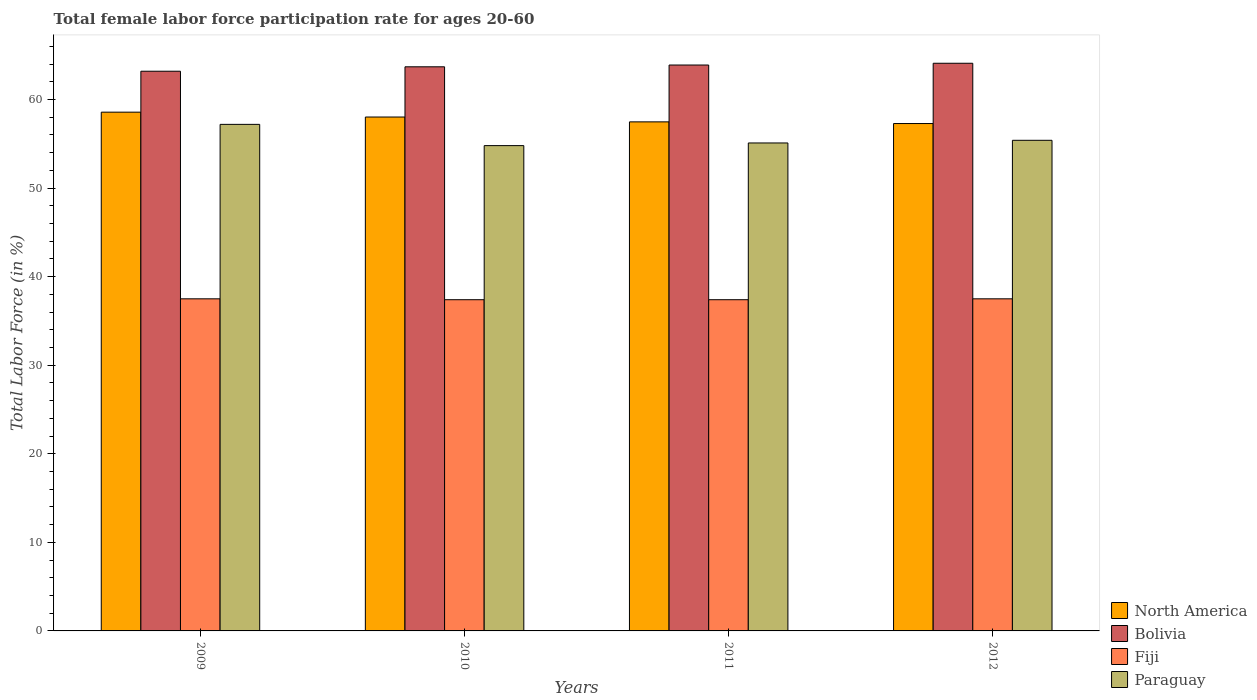How many different coloured bars are there?
Offer a terse response. 4. Are the number of bars per tick equal to the number of legend labels?
Ensure brevity in your answer.  Yes. How many bars are there on the 4th tick from the left?
Your answer should be compact. 4. What is the female labor force participation rate in Paraguay in 2011?
Offer a terse response. 55.1. Across all years, what is the maximum female labor force participation rate in North America?
Offer a very short reply. 58.58. Across all years, what is the minimum female labor force participation rate in Bolivia?
Provide a short and direct response. 63.2. What is the total female labor force participation rate in Fiji in the graph?
Your response must be concise. 149.8. What is the difference between the female labor force participation rate in North America in 2009 and that in 2010?
Keep it short and to the point. 0.55. What is the difference between the female labor force participation rate in Paraguay in 2009 and the female labor force participation rate in Fiji in 2012?
Provide a succinct answer. 19.7. What is the average female labor force participation rate in North America per year?
Offer a terse response. 57.85. In the year 2009, what is the difference between the female labor force participation rate in Fiji and female labor force participation rate in North America?
Provide a succinct answer. -21.08. In how many years, is the female labor force participation rate in North America greater than 4 %?
Your answer should be compact. 4. What is the ratio of the female labor force participation rate in Paraguay in 2009 to that in 2011?
Provide a succinct answer. 1.04. What is the difference between the highest and the second highest female labor force participation rate in Paraguay?
Give a very brief answer. 1.8. What is the difference between the highest and the lowest female labor force participation rate in North America?
Your response must be concise. 1.28. Is the sum of the female labor force participation rate in North America in 2011 and 2012 greater than the maximum female labor force participation rate in Bolivia across all years?
Provide a succinct answer. Yes. What does the 4th bar from the left in 2009 represents?
Offer a terse response. Paraguay. Is it the case that in every year, the sum of the female labor force participation rate in North America and female labor force participation rate in Paraguay is greater than the female labor force participation rate in Fiji?
Give a very brief answer. Yes. How many bars are there?
Your answer should be very brief. 16. How many years are there in the graph?
Provide a succinct answer. 4. What is the difference between two consecutive major ticks on the Y-axis?
Ensure brevity in your answer.  10. Does the graph contain grids?
Offer a very short reply. No. Where does the legend appear in the graph?
Your answer should be very brief. Bottom right. How are the legend labels stacked?
Give a very brief answer. Vertical. What is the title of the graph?
Your response must be concise. Total female labor force participation rate for ages 20-60. Does "Timor-Leste" appear as one of the legend labels in the graph?
Ensure brevity in your answer.  No. What is the Total Labor Force (in %) of North America in 2009?
Offer a terse response. 58.58. What is the Total Labor Force (in %) of Bolivia in 2009?
Your answer should be very brief. 63.2. What is the Total Labor Force (in %) in Fiji in 2009?
Your response must be concise. 37.5. What is the Total Labor Force (in %) in Paraguay in 2009?
Your answer should be compact. 57.2. What is the Total Labor Force (in %) in North America in 2010?
Offer a very short reply. 58.03. What is the Total Labor Force (in %) of Bolivia in 2010?
Keep it short and to the point. 63.7. What is the Total Labor Force (in %) in Fiji in 2010?
Your answer should be very brief. 37.4. What is the Total Labor Force (in %) of Paraguay in 2010?
Make the answer very short. 54.8. What is the Total Labor Force (in %) in North America in 2011?
Make the answer very short. 57.48. What is the Total Labor Force (in %) in Bolivia in 2011?
Offer a very short reply. 63.9. What is the Total Labor Force (in %) of Fiji in 2011?
Provide a short and direct response. 37.4. What is the Total Labor Force (in %) of Paraguay in 2011?
Provide a short and direct response. 55.1. What is the Total Labor Force (in %) of North America in 2012?
Offer a terse response. 57.29. What is the Total Labor Force (in %) in Bolivia in 2012?
Provide a succinct answer. 64.1. What is the Total Labor Force (in %) of Fiji in 2012?
Your answer should be compact. 37.5. What is the Total Labor Force (in %) of Paraguay in 2012?
Ensure brevity in your answer.  55.4. Across all years, what is the maximum Total Labor Force (in %) of North America?
Offer a very short reply. 58.58. Across all years, what is the maximum Total Labor Force (in %) of Bolivia?
Give a very brief answer. 64.1. Across all years, what is the maximum Total Labor Force (in %) in Fiji?
Make the answer very short. 37.5. Across all years, what is the maximum Total Labor Force (in %) in Paraguay?
Your answer should be compact. 57.2. Across all years, what is the minimum Total Labor Force (in %) of North America?
Offer a very short reply. 57.29. Across all years, what is the minimum Total Labor Force (in %) of Bolivia?
Keep it short and to the point. 63.2. Across all years, what is the minimum Total Labor Force (in %) in Fiji?
Offer a terse response. 37.4. Across all years, what is the minimum Total Labor Force (in %) of Paraguay?
Provide a succinct answer. 54.8. What is the total Total Labor Force (in %) in North America in the graph?
Give a very brief answer. 231.38. What is the total Total Labor Force (in %) in Bolivia in the graph?
Your answer should be very brief. 254.9. What is the total Total Labor Force (in %) of Fiji in the graph?
Your response must be concise. 149.8. What is the total Total Labor Force (in %) in Paraguay in the graph?
Provide a short and direct response. 222.5. What is the difference between the Total Labor Force (in %) in North America in 2009 and that in 2010?
Give a very brief answer. 0.55. What is the difference between the Total Labor Force (in %) in Bolivia in 2009 and that in 2010?
Your response must be concise. -0.5. What is the difference between the Total Labor Force (in %) in Fiji in 2009 and that in 2010?
Make the answer very short. 0.1. What is the difference between the Total Labor Force (in %) in North America in 2009 and that in 2011?
Offer a terse response. 1.1. What is the difference between the Total Labor Force (in %) in North America in 2009 and that in 2012?
Provide a short and direct response. 1.28. What is the difference between the Total Labor Force (in %) in Fiji in 2009 and that in 2012?
Your answer should be compact. 0. What is the difference between the Total Labor Force (in %) in North America in 2010 and that in 2011?
Provide a short and direct response. 0.55. What is the difference between the Total Labor Force (in %) of Bolivia in 2010 and that in 2011?
Provide a short and direct response. -0.2. What is the difference between the Total Labor Force (in %) of Paraguay in 2010 and that in 2011?
Your response must be concise. -0.3. What is the difference between the Total Labor Force (in %) in North America in 2010 and that in 2012?
Provide a short and direct response. 0.74. What is the difference between the Total Labor Force (in %) in Paraguay in 2010 and that in 2012?
Make the answer very short. -0.6. What is the difference between the Total Labor Force (in %) in North America in 2011 and that in 2012?
Ensure brevity in your answer.  0.19. What is the difference between the Total Labor Force (in %) of Paraguay in 2011 and that in 2012?
Give a very brief answer. -0.3. What is the difference between the Total Labor Force (in %) in North America in 2009 and the Total Labor Force (in %) in Bolivia in 2010?
Your answer should be very brief. -5.12. What is the difference between the Total Labor Force (in %) in North America in 2009 and the Total Labor Force (in %) in Fiji in 2010?
Offer a terse response. 21.18. What is the difference between the Total Labor Force (in %) in North America in 2009 and the Total Labor Force (in %) in Paraguay in 2010?
Provide a succinct answer. 3.78. What is the difference between the Total Labor Force (in %) in Bolivia in 2009 and the Total Labor Force (in %) in Fiji in 2010?
Your answer should be very brief. 25.8. What is the difference between the Total Labor Force (in %) in Bolivia in 2009 and the Total Labor Force (in %) in Paraguay in 2010?
Ensure brevity in your answer.  8.4. What is the difference between the Total Labor Force (in %) in Fiji in 2009 and the Total Labor Force (in %) in Paraguay in 2010?
Offer a very short reply. -17.3. What is the difference between the Total Labor Force (in %) in North America in 2009 and the Total Labor Force (in %) in Bolivia in 2011?
Make the answer very short. -5.32. What is the difference between the Total Labor Force (in %) in North America in 2009 and the Total Labor Force (in %) in Fiji in 2011?
Give a very brief answer. 21.18. What is the difference between the Total Labor Force (in %) in North America in 2009 and the Total Labor Force (in %) in Paraguay in 2011?
Keep it short and to the point. 3.48. What is the difference between the Total Labor Force (in %) of Bolivia in 2009 and the Total Labor Force (in %) of Fiji in 2011?
Your answer should be compact. 25.8. What is the difference between the Total Labor Force (in %) of Bolivia in 2009 and the Total Labor Force (in %) of Paraguay in 2011?
Ensure brevity in your answer.  8.1. What is the difference between the Total Labor Force (in %) of Fiji in 2009 and the Total Labor Force (in %) of Paraguay in 2011?
Your answer should be very brief. -17.6. What is the difference between the Total Labor Force (in %) of North America in 2009 and the Total Labor Force (in %) of Bolivia in 2012?
Give a very brief answer. -5.52. What is the difference between the Total Labor Force (in %) in North America in 2009 and the Total Labor Force (in %) in Fiji in 2012?
Your answer should be very brief. 21.08. What is the difference between the Total Labor Force (in %) in North America in 2009 and the Total Labor Force (in %) in Paraguay in 2012?
Keep it short and to the point. 3.18. What is the difference between the Total Labor Force (in %) of Bolivia in 2009 and the Total Labor Force (in %) of Fiji in 2012?
Ensure brevity in your answer.  25.7. What is the difference between the Total Labor Force (in %) in Bolivia in 2009 and the Total Labor Force (in %) in Paraguay in 2012?
Give a very brief answer. 7.8. What is the difference between the Total Labor Force (in %) in Fiji in 2009 and the Total Labor Force (in %) in Paraguay in 2012?
Keep it short and to the point. -17.9. What is the difference between the Total Labor Force (in %) in North America in 2010 and the Total Labor Force (in %) in Bolivia in 2011?
Ensure brevity in your answer.  -5.87. What is the difference between the Total Labor Force (in %) in North America in 2010 and the Total Labor Force (in %) in Fiji in 2011?
Provide a succinct answer. 20.63. What is the difference between the Total Labor Force (in %) in North America in 2010 and the Total Labor Force (in %) in Paraguay in 2011?
Ensure brevity in your answer.  2.93. What is the difference between the Total Labor Force (in %) in Bolivia in 2010 and the Total Labor Force (in %) in Fiji in 2011?
Ensure brevity in your answer.  26.3. What is the difference between the Total Labor Force (in %) of Bolivia in 2010 and the Total Labor Force (in %) of Paraguay in 2011?
Provide a short and direct response. 8.6. What is the difference between the Total Labor Force (in %) of Fiji in 2010 and the Total Labor Force (in %) of Paraguay in 2011?
Your answer should be very brief. -17.7. What is the difference between the Total Labor Force (in %) in North America in 2010 and the Total Labor Force (in %) in Bolivia in 2012?
Make the answer very short. -6.07. What is the difference between the Total Labor Force (in %) in North America in 2010 and the Total Labor Force (in %) in Fiji in 2012?
Provide a short and direct response. 20.53. What is the difference between the Total Labor Force (in %) in North America in 2010 and the Total Labor Force (in %) in Paraguay in 2012?
Your response must be concise. 2.63. What is the difference between the Total Labor Force (in %) of Bolivia in 2010 and the Total Labor Force (in %) of Fiji in 2012?
Offer a very short reply. 26.2. What is the difference between the Total Labor Force (in %) of Bolivia in 2010 and the Total Labor Force (in %) of Paraguay in 2012?
Your answer should be compact. 8.3. What is the difference between the Total Labor Force (in %) of Fiji in 2010 and the Total Labor Force (in %) of Paraguay in 2012?
Give a very brief answer. -18. What is the difference between the Total Labor Force (in %) of North America in 2011 and the Total Labor Force (in %) of Bolivia in 2012?
Offer a very short reply. -6.62. What is the difference between the Total Labor Force (in %) in North America in 2011 and the Total Labor Force (in %) in Fiji in 2012?
Provide a short and direct response. 19.98. What is the difference between the Total Labor Force (in %) in North America in 2011 and the Total Labor Force (in %) in Paraguay in 2012?
Your answer should be very brief. 2.08. What is the difference between the Total Labor Force (in %) in Bolivia in 2011 and the Total Labor Force (in %) in Fiji in 2012?
Your answer should be very brief. 26.4. What is the difference between the Total Labor Force (in %) of Bolivia in 2011 and the Total Labor Force (in %) of Paraguay in 2012?
Make the answer very short. 8.5. What is the average Total Labor Force (in %) in North America per year?
Your answer should be compact. 57.85. What is the average Total Labor Force (in %) of Bolivia per year?
Give a very brief answer. 63.73. What is the average Total Labor Force (in %) of Fiji per year?
Give a very brief answer. 37.45. What is the average Total Labor Force (in %) in Paraguay per year?
Ensure brevity in your answer.  55.62. In the year 2009, what is the difference between the Total Labor Force (in %) in North America and Total Labor Force (in %) in Bolivia?
Keep it short and to the point. -4.62. In the year 2009, what is the difference between the Total Labor Force (in %) in North America and Total Labor Force (in %) in Fiji?
Give a very brief answer. 21.08. In the year 2009, what is the difference between the Total Labor Force (in %) of North America and Total Labor Force (in %) of Paraguay?
Make the answer very short. 1.38. In the year 2009, what is the difference between the Total Labor Force (in %) of Bolivia and Total Labor Force (in %) of Fiji?
Offer a very short reply. 25.7. In the year 2009, what is the difference between the Total Labor Force (in %) of Bolivia and Total Labor Force (in %) of Paraguay?
Provide a short and direct response. 6. In the year 2009, what is the difference between the Total Labor Force (in %) in Fiji and Total Labor Force (in %) in Paraguay?
Give a very brief answer. -19.7. In the year 2010, what is the difference between the Total Labor Force (in %) of North America and Total Labor Force (in %) of Bolivia?
Make the answer very short. -5.67. In the year 2010, what is the difference between the Total Labor Force (in %) of North America and Total Labor Force (in %) of Fiji?
Your answer should be very brief. 20.63. In the year 2010, what is the difference between the Total Labor Force (in %) in North America and Total Labor Force (in %) in Paraguay?
Make the answer very short. 3.23. In the year 2010, what is the difference between the Total Labor Force (in %) of Bolivia and Total Labor Force (in %) of Fiji?
Provide a succinct answer. 26.3. In the year 2010, what is the difference between the Total Labor Force (in %) in Fiji and Total Labor Force (in %) in Paraguay?
Give a very brief answer. -17.4. In the year 2011, what is the difference between the Total Labor Force (in %) of North America and Total Labor Force (in %) of Bolivia?
Ensure brevity in your answer.  -6.42. In the year 2011, what is the difference between the Total Labor Force (in %) in North America and Total Labor Force (in %) in Fiji?
Make the answer very short. 20.08. In the year 2011, what is the difference between the Total Labor Force (in %) of North America and Total Labor Force (in %) of Paraguay?
Provide a short and direct response. 2.38. In the year 2011, what is the difference between the Total Labor Force (in %) of Bolivia and Total Labor Force (in %) of Paraguay?
Ensure brevity in your answer.  8.8. In the year 2011, what is the difference between the Total Labor Force (in %) of Fiji and Total Labor Force (in %) of Paraguay?
Make the answer very short. -17.7. In the year 2012, what is the difference between the Total Labor Force (in %) in North America and Total Labor Force (in %) in Bolivia?
Your answer should be very brief. -6.81. In the year 2012, what is the difference between the Total Labor Force (in %) of North America and Total Labor Force (in %) of Fiji?
Offer a terse response. 19.79. In the year 2012, what is the difference between the Total Labor Force (in %) of North America and Total Labor Force (in %) of Paraguay?
Your answer should be very brief. 1.89. In the year 2012, what is the difference between the Total Labor Force (in %) of Bolivia and Total Labor Force (in %) of Fiji?
Your answer should be very brief. 26.6. In the year 2012, what is the difference between the Total Labor Force (in %) in Bolivia and Total Labor Force (in %) in Paraguay?
Your response must be concise. 8.7. In the year 2012, what is the difference between the Total Labor Force (in %) in Fiji and Total Labor Force (in %) in Paraguay?
Keep it short and to the point. -17.9. What is the ratio of the Total Labor Force (in %) in North America in 2009 to that in 2010?
Provide a short and direct response. 1.01. What is the ratio of the Total Labor Force (in %) of Bolivia in 2009 to that in 2010?
Your response must be concise. 0.99. What is the ratio of the Total Labor Force (in %) of Paraguay in 2009 to that in 2010?
Your answer should be compact. 1.04. What is the ratio of the Total Labor Force (in %) of North America in 2009 to that in 2011?
Your answer should be very brief. 1.02. What is the ratio of the Total Labor Force (in %) of Fiji in 2009 to that in 2011?
Your answer should be compact. 1. What is the ratio of the Total Labor Force (in %) of Paraguay in 2009 to that in 2011?
Make the answer very short. 1.04. What is the ratio of the Total Labor Force (in %) in North America in 2009 to that in 2012?
Your answer should be very brief. 1.02. What is the ratio of the Total Labor Force (in %) of Bolivia in 2009 to that in 2012?
Your answer should be compact. 0.99. What is the ratio of the Total Labor Force (in %) in Paraguay in 2009 to that in 2012?
Provide a succinct answer. 1.03. What is the ratio of the Total Labor Force (in %) of North America in 2010 to that in 2011?
Offer a very short reply. 1.01. What is the ratio of the Total Labor Force (in %) of Fiji in 2010 to that in 2011?
Your response must be concise. 1. What is the ratio of the Total Labor Force (in %) of North America in 2010 to that in 2012?
Offer a very short reply. 1.01. What is the ratio of the Total Labor Force (in %) in Paraguay in 2010 to that in 2012?
Your response must be concise. 0.99. What is the ratio of the Total Labor Force (in %) in North America in 2011 to that in 2012?
Your answer should be very brief. 1. What is the ratio of the Total Labor Force (in %) in Bolivia in 2011 to that in 2012?
Keep it short and to the point. 1. What is the ratio of the Total Labor Force (in %) of Fiji in 2011 to that in 2012?
Keep it short and to the point. 1. What is the ratio of the Total Labor Force (in %) in Paraguay in 2011 to that in 2012?
Offer a terse response. 0.99. What is the difference between the highest and the second highest Total Labor Force (in %) in North America?
Offer a terse response. 0.55. What is the difference between the highest and the second highest Total Labor Force (in %) of Bolivia?
Offer a terse response. 0.2. What is the difference between the highest and the second highest Total Labor Force (in %) of Paraguay?
Provide a short and direct response. 1.8. What is the difference between the highest and the lowest Total Labor Force (in %) of North America?
Make the answer very short. 1.28. What is the difference between the highest and the lowest Total Labor Force (in %) of Paraguay?
Make the answer very short. 2.4. 